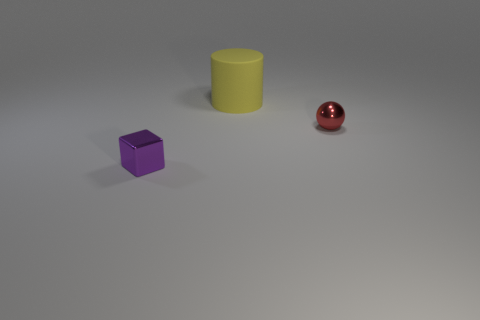Is there any other thing that is the same size as the cylinder?
Offer a terse response. No. There is a object that is the same size as the red metallic sphere; what material is it?
Give a very brief answer. Metal. There is a cylinder; does it have the same size as the shiny object in front of the tiny metal ball?
Keep it short and to the point. No. What is the material of the small object to the left of the large yellow rubber cylinder?
Make the answer very short. Metal. Are there an equal number of tiny red spheres on the left side of the tiny sphere and yellow cylinders?
Provide a succinct answer. No. Do the purple metallic thing and the red ball have the same size?
Your answer should be compact. Yes. There is a small shiny thing that is in front of the tiny object that is to the right of the big yellow rubber object; are there any shiny cubes that are on the left side of it?
Offer a very short reply. No. There is a thing on the right side of the large yellow rubber cylinder; what number of small red metallic balls are behind it?
Give a very brief answer. 0. How big is the metallic thing that is behind the purple metal block that is to the left of the tiny metallic object behind the shiny block?
Provide a short and direct response. Small. There is a metal thing that is behind the shiny object to the left of the small red thing; what is its color?
Ensure brevity in your answer.  Red. 